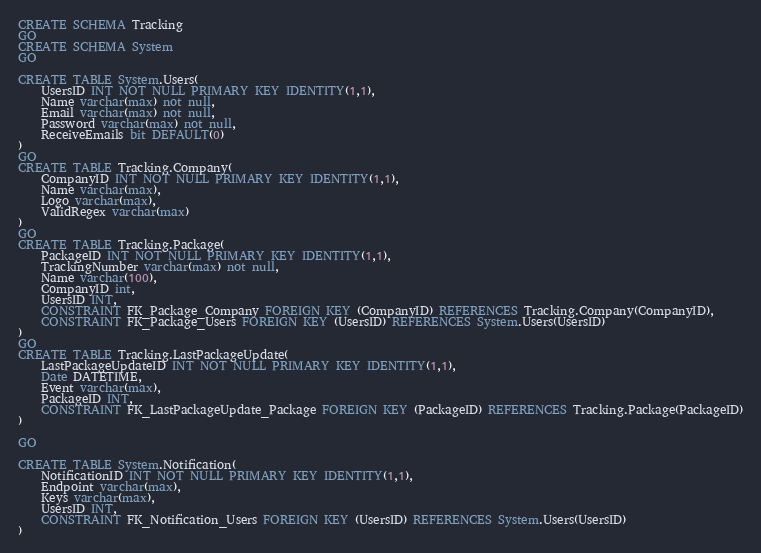<code> <loc_0><loc_0><loc_500><loc_500><_SQL_>CREATE SCHEMA Tracking
GO
CREATE SCHEMA System
GO

CREATE TABLE System.Users(
	UsersID INT NOT NULL PRIMARY KEY IDENTITY(1,1),
	Name varchar(max) not null,
	Email varchar(max) not null,
	Password varchar(max) not null,
	ReceiveEmails bit DEFAULT(0)
)
GO
CREATE TABLE Tracking.Company(
	CompanyID INT NOT NULL PRIMARY KEY IDENTITY(1,1),
	Name varchar(max),
	Logo varchar(max),
	ValidRegex varchar(max)
)
GO
CREATE TABLE Tracking.Package(
	PackageID INT NOT NULL PRIMARY KEY IDENTITY(1,1),
	TrackingNumber varchar(max) not null,
	Name varchar(100),
	CompanyID int,
	UsersID INT, 
	CONSTRAINT FK_Package_Company FOREIGN KEY (CompanyID) REFERENCES Tracking.Company(CompanyID),
	CONSTRAINT FK_Package_Users FOREIGN KEY (UsersID) REFERENCES System.Users(UsersID)
)
GO
CREATE TABLE Tracking.LastPackageUpdate(
	LastPackageUpdateID INT NOT NULL PRIMARY KEY IDENTITY(1,1),
	Date DATETIME,
	Event varchar(max),
	PackageID INT,
	CONSTRAINT FK_LastPackageUpdate_Package FOREIGN KEY (PackageID) REFERENCES Tracking.Package(PackageID)
)

GO

CREATE TABLE System.Notification(
	NotificationID INT NOT NULL PRIMARY KEY IDENTITY(1,1),
	Endpoint varchar(max),
	Keys varchar(max),
	UsersID INT,
	CONSTRAINT FK_Notification_Users FOREIGN KEY (UsersID) REFERENCES System.Users(UsersID)
)
</code> 